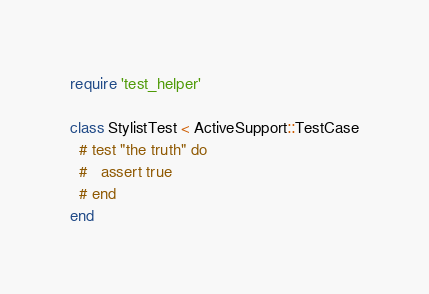<code> <loc_0><loc_0><loc_500><loc_500><_Ruby_>require 'test_helper'

class StylistTest < ActiveSupport::TestCase
  # test "the truth" do
  #   assert true
  # end
end
</code> 